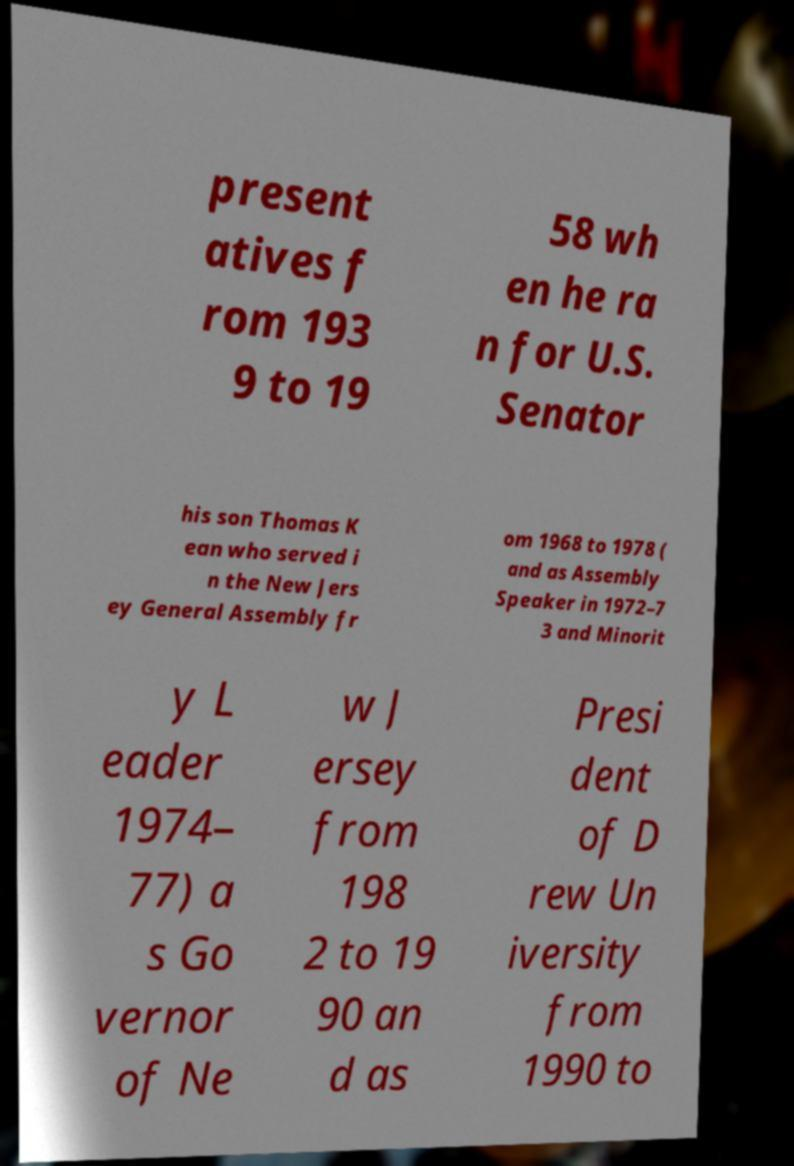Could you extract and type out the text from this image? present atives f rom 193 9 to 19 58 wh en he ra n for U.S. Senator his son Thomas K ean who served i n the New Jers ey General Assembly fr om 1968 to 1978 ( and as Assembly Speaker in 1972–7 3 and Minorit y L eader 1974– 77) a s Go vernor of Ne w J ersey from 198 2 to 19 90 an d as Presi dent of D rew Un iversity from 1990 to 